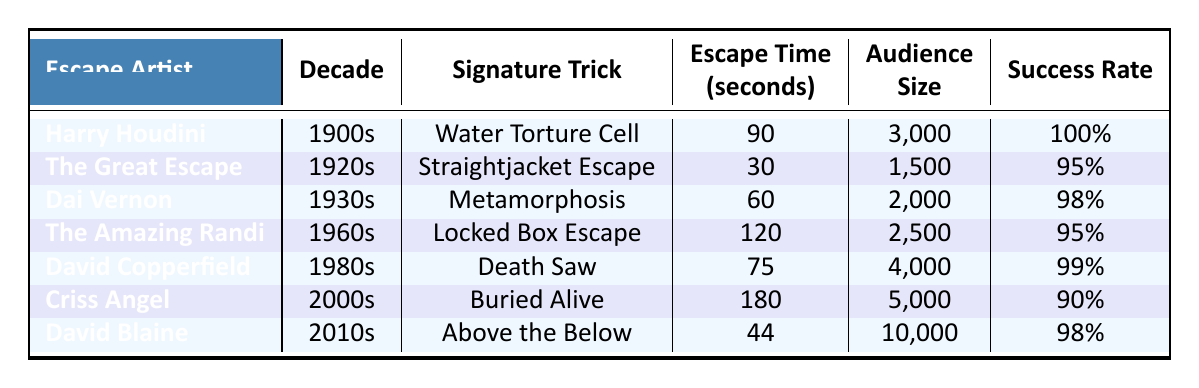What signature trick did David Blaine perform? By checking the table, David Blaine's entry shows "Above the Below" listed as his signature trick.
Answer: Above the Below Which escape artist had the highest audience size? Looking at the audience sizes, David Blaine's audience was 10,000, which is greater than any other escape artist listed.
Answer: David Blaine What is the average escape time of all the escape artists in the table? The escape times are 90, 30, 60, 120, 75, 180, and 44 seconds, which sum up to 599 seconds. There are 7 data points, so the average is 599 / 7 = 85.57 seconds.
Answer: 85.57 seconds Did any escape artist perform with a success rate of 100%? Checking the table shows that only Harry Houdini has a success rate of 100%.
Answer: Yes Which escape artist had the quickest escape time during the 1920s? Referring to the 1920s row, The Great Escape had an escape time of 30 seconds, which is the quickest escape time for that decade.
Answer: The Great Escape 